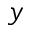<formula> <loc_0><loc_0><loc_500><loc_500>y</formula> 